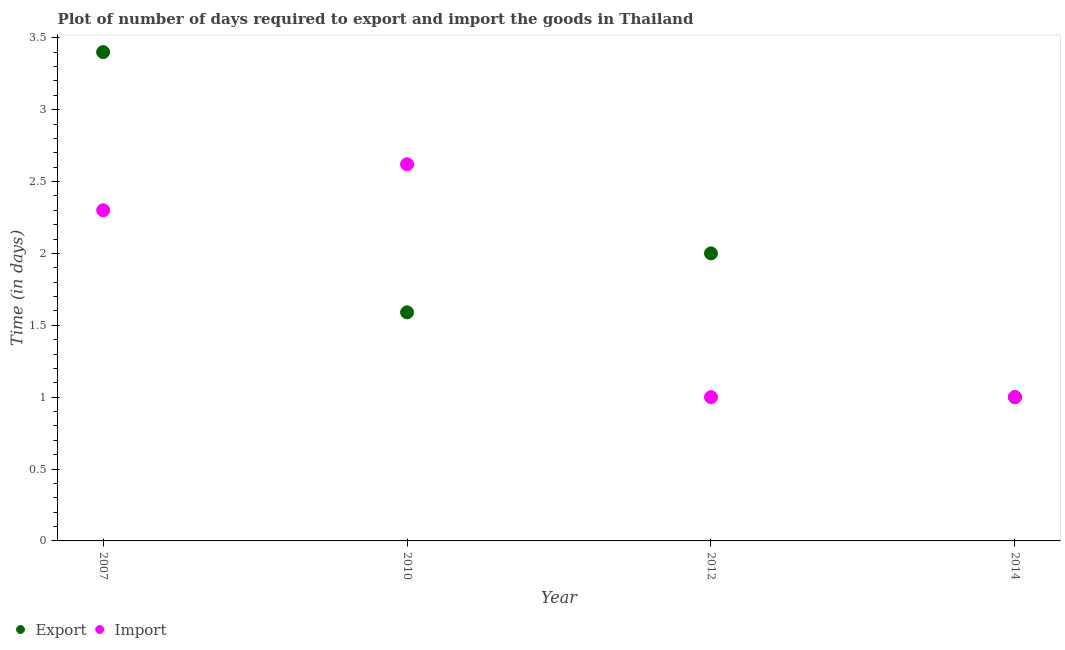How many different coloured dotlines are there?
Your answer should be very brief. 2. What is the time required to import in 2007?
Ensure brevity in your answer.  2.3. Across all years, what is the maximum time required to import?
Make the answer very short. 2.62. In which year was the time required to import maximum?
Offer a terse response. 2010. In which year was the time required to import minimum?
Ensure brevity in your answer.  2012. What is the total time required to export in the graph?
Offer a very short reply. 7.99. What is the difference between the time required to import in 2007 and that in 2012?
Make the answer very short. 1.3. What is the difference between the time required to export in 2007 and the time required to import in 2010?
Ensure brevity in your answer.  0.78. What is the average time required to export per year?
Give a very brief answer. 2. In how many years, is the time required to import greater than 2.3 days?
Provide a short and direct response. 1. What is the ratio of the time required to export in 2007 to that in 2014?
Provide a short and direct response. 3.4. Is the difference between the time required to export in 2007 and 2014 greater than the difference between the time required to import in 2007 and 2014?
Keep it short and to the point. Yes. What is the difference between the highest and the second highest time required to export?
Offer a very short reply. 1.4. What is the difference between the highest and the lowest time required to export?
Your response must be concise. 2.4. In how many years, is the time required to import greater than the average time required to import taken over all years?
Provide a short and direct response. 2. Does the time required to export monotonically increase over the years?
Offer a terse response. No. Is the time required to export strictly less than the time required to import over the years?
Give a very brief answer. No. What is the difference between two consecutive major ticks on the Y-axis?
Offer a terse response. 0.5. Does the graph contain any zero values?
Your answer should be compact. No. Does the graph contain grids?
Ensure brevity in your answer.  No. How are the legend labels stacked?
Give a very brief answer. Horizontal. What is the title of the graph?
Your response must be concise. Plot of number of days required to export and import the goods in Thailand. Does "Current education expenditure" appear as one of the legend labels in the graph?
Keep it short and to the point. No. What is the label or title of the X-axis?
Your response must be concise. Year. What is the label or title of the Y-axis?
Your answer should be very brief. Time (in days). What is the Time (in days) in Export in 2010?
Your answer should be compact. 1.59. What is the Time (in days) of Import in 2010?
Ensure brevity in your answer.  2.62. What is the Time (in days) in Import in 2012?
Your response must be concise. 1. What is the Time (in days) in Export in 2014?
Your response must be concise. 1. What is the Time (in days) in Import in 2014?
Give a very brief answer. 1. Across all years, what is the maximum Time (in days) of Import?
Offer a terse response. 2.62. Across all years, what is the minimum Time (in days) of Export?
Your answer should be very brief. 1. Across all years, what is the minimum Time (in days) of Import?
Keep it short and to the point. 1. What is the total Time (in days) in Export in the graph?
Your answer should be compact. 7.99. What is the total Time (in days) in Import in the graph?
Your answer should be compact. 6.92. What is the difference between the Time (in days) of Export in 2007 and that in 2010?
Your response must be concise. 1.81. What is the difference between the Time (in days) of Import in 2007 and that in 2010?
Your answer should be compact. -0.32. What is the difference between the Time (in days) of Export in 2007 and that in 2014?
Provide a short and direct response. 2.4. What is the difference between the Time (in days) in Export in 2010 and that in 2012?
Ensure brevity in your answer.  -0.41. What is the difference between the Time (in days) of Import in 2010 and that in 2012?
Provide a short and direct response. 1.62. What is the difference between the Time (in days) in Export in 2010 and that in 2014?
Make the answer very short. 0.59. What is the difference between the Time (in days) of Import in 2010 and that in 2014?
Offer a terse response. 1.62. What is the difference between the Time (in days) of Export in 2012 and that in 2014?
Your response must be concise. 1. What is the difference between the Time (in days) in Export in 2007 and the Time (in days) in Import in 2010?
Provide a succinct answer. 0.78. What is the difference between the Time (in days) of Export in 2007 and the Time (in days) of Import in 2012?
Keep it short and to the point. 2.4. What is the difference between the Time (in days) of Export in 2007 and the Time (in days) of Import in 2014?
Your answer should be very brief. 2.4. What is the difference between the Time (in days) of Export in 2010 and the Time (in days) of Import in 2012?
Give a very brief answer. 0.59. What is the difference between the Time (in days) in Export in 2010 and the Time (in days) in Import in 2014?
Ensure brevity in your answer.  0.59. What is the difference between the Time (in days) of Export in 2012 and the Time (in days) of Import in 2014?
Make the answer very short. 1. What is the average Time (in days) in Export per year?
Your answer should be very brief. 2. What is the average Time (in days) in Import per year?
Your answer should be compact. 1.73. In the year 2010, what is the difference between the Time (in days) in Export and Time (in days) in Import?
Keep it short and to the point. -1.03. In the year 2012, what is the difference between the Time (in days) in Export and Time (in days) in Import?
Give a very brief answer. 1. What is the ratio of the Time (in days) of Export in 2007 to that in 2010?
Your answer should be compact. 2.14. What is the ratio of the Time (in days) in Import in 2007 to that in 2010?
Your answer should be very brief. 0.88. What is the ratio of the Time (in days) of Export in 2007 to that in 2012?
Provide a short and direct response. 1.7. What is the ratio of the Time (in days) in Export in 2007 to that in 2014?
Your answer should be compact. 3.4. What is the ratio of the Time (in days) of Import in 2007 to that in 2014?
Your response must be concise. 2.3. What is the ratio of the Time (in days) of Export in 2010 to that in 2012?
Offer a terse response. 0.8. What is the ratio of the Time (in days) in Import in 2010 to that in 2012?
Offer a very short reply. 2.62. What is the ratio of the Time (in days) in Export in 2010 to that in 2014?
Provide a succinct answer. 1.59. What is the ratio of the Time (in days) in Import in 2010 to that in 2014?
Offer a very short reply. 2.62. What is the ratio of the Time (in days) in Import in 2012 to that in 2014?
Keep it short and to the point. 1. What is the difference between the highest and the second highest Time (in days) of Export?
Your answer should be very brief. 1.4. What is the difference between the highest and the second highest Time (in days) of Import?
Offer a terse response. 0.32. What is the difference between the highest and the lowest Time (in days) of Export?
Give a very brief answer. 2.4. What is the difference between the highest and the lowest Time (in days) in Import?
Offer a terse response. 1.62. 